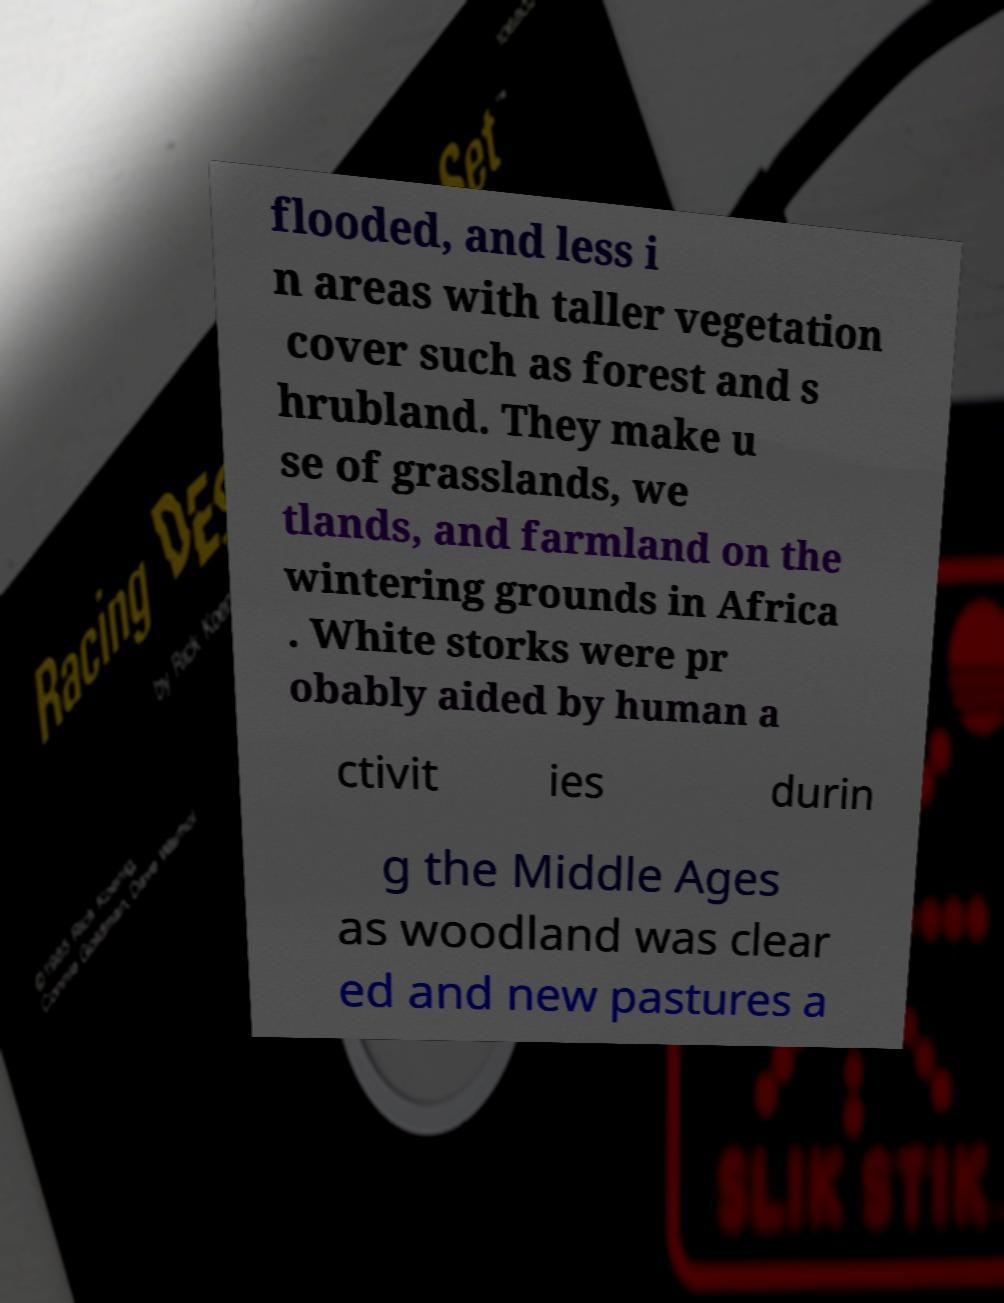What messages or text are displayed in this image? I need them in a readable, typed format. flooded, and less i n areas with taller vegetation cover such as forest and s hrubland. They make u se of grasslands, we tlands, and farmland on the wintering grounds in Africa . White storks were pr obably aided by human a ctivit ies durin g the Middle Ages as woodland was clear ed and new pastures a 